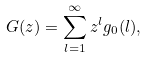Convert formula to latex. <formula><loc_0><loc_0><loc_500><loc_500>G ( z ) = \sum _ { l = 1 } ^ { \infty } z ^ { l } g _ { 0 } ( l ) ,</formula> 